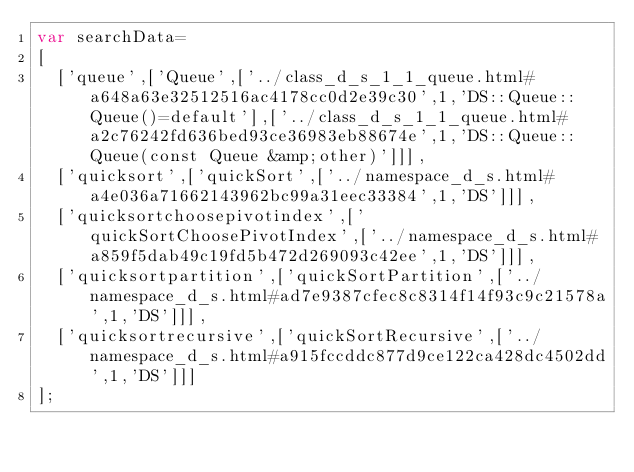<code> <loc_0><loc_0><loc_500><loc_500><_JavaScript_>var searchData=
[
  ['queue',['Queue',['../class_d_s_1_1_queue.html#a648a63e32512516ac4178cc0d2e39c30',1,'DS::Queue::Queue()=default'],['../class_d_s_1_1_queue.html#a2c76242fd636bed93ce36983eb88674e',1,'DS::Queue::Queue(const Queue &amp;other)']]],
  ['quicksort',['quickSort',['../namespace_d_s.html#a4e036a71662143962bc99a31eec33384',1,'DS']]],
  ['quicksortchoosepivotindex',['quickSortChoosePivotIndex',['../namespace_d_s.html#a859f5dab49c19fd5b472d269093c42ee',1,'DS']]],
  ['quicksortpartition',['quickSortPartition',['../namespace_d_s.html#ad7e9387cfec8c8314f14f93c9c21578a',1,'DS']]],
  ['quicksortrecursive',['quickSortRecursive',['../namespace_d_s.html#a915fccddc877d9ce122ca428dc4502dd',1,'DS']]]
];
</code> 